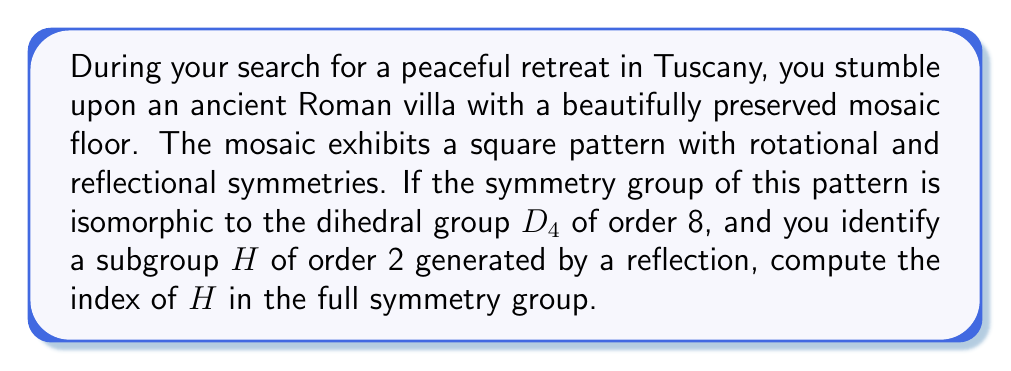Show me your answer to this math problem. Let's approach this step-by-step:

1) First, recall that the index of a subgroup $H$ in a group $G$ is defined as:

   $[G:H] = \frac{|G|}{|H|}$

   where $|G|$ and $|H|$ are the orders of $G$ and $H$ respectively.

2) We're given that the symmetry group of the mosaic pattern is isomorphic to $D_4$. The dihedral group $D_4$ has order 8, so:

   $|G| = 8$

3) We're also told that $H$ is a subgroup of order 2:

   $|H| = 2$

4) Now we can simply substitute these values into our formula:

   $[G:H] = \frac{|G|}{|H|} = \frac{8}{2} = 4$

5) To understand this geometrically, we can think of the cosets of $H$ in $G$. Since $H$ is generated by a reflection, its cosets will correspond to:
   - The identity and the reflection (which form $H$ itself)
   - A 90° rotation and its composition with the reflection
   - A 180° rotation and its composition with the reflection
   - A 270° rotation and its composition with the reflection

   This gives us 4 distinct cosets, which matches our calculated index.
Answer: The index of $H$ in the symmetry group is 4. 